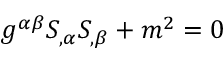<formula> <loc_0><loc_0><loc_500><loc_500>g ^ { \alpha \beta } S _ { , \alpha } S _ { , \beta } + m ^ { 2 } = 0</formula> 